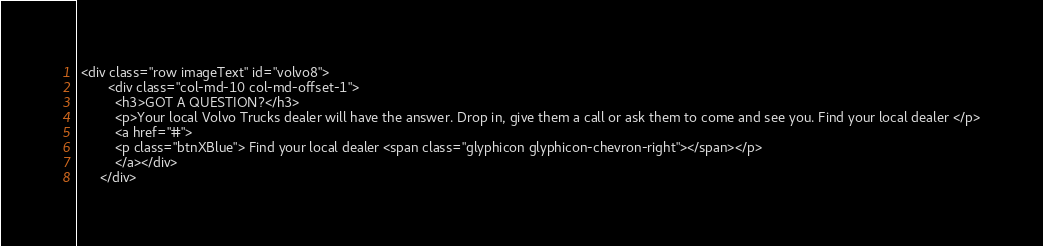Convert code to text. <code><loc_0><loc_0><loc_500><loc_500><_PHP_> <div class="row imageText" id="volvo8">
        <div class="col-md-10 col-md-offset-1">
          <h3>GOT A QUESTION?</h3>
          <p>Your local Volvo Trucks dealer will have the answer. Drop in, give them a call or ask them to come and see you. Find your local dealer </p>
          <a href="#">
          <p class="btnXBlue"> Find your local dealer <span class="glyphicon glyphicon-chevron-right"></span></p>
          </a></div>
      </div></code> 